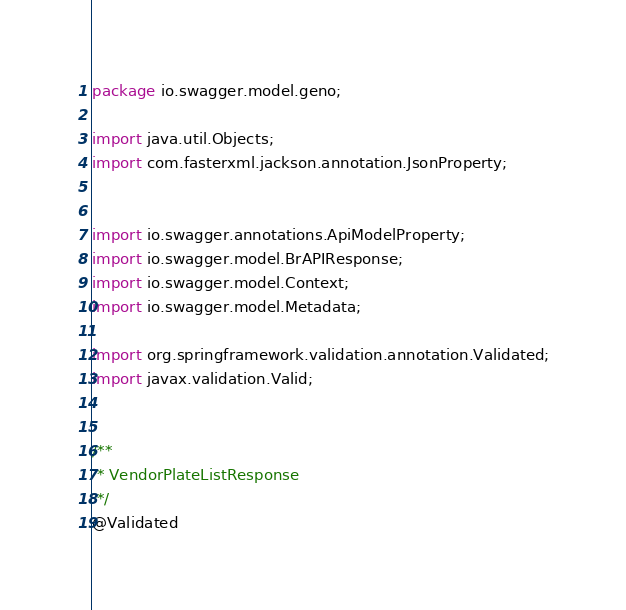Convert code to text. <code><loc_0><loc_0><loc_500><loc_500><_Java_>package io.swagger.model.geno;

import java.util.Objects;
import com.fasterxml.jackson.annotation.JsonProperty;


import io.swagger.annotations.ApiModelProperty;
import io.swagger.model.BrAPIResponse;
import io.swagger.model.Context;
import io.swagger.model.Metadata;

import org.springframework.validation.annotation.Validated;
import javax.validation.Valid;


/**
 * VendorPlateListResponse
 */
@Validated</code> 